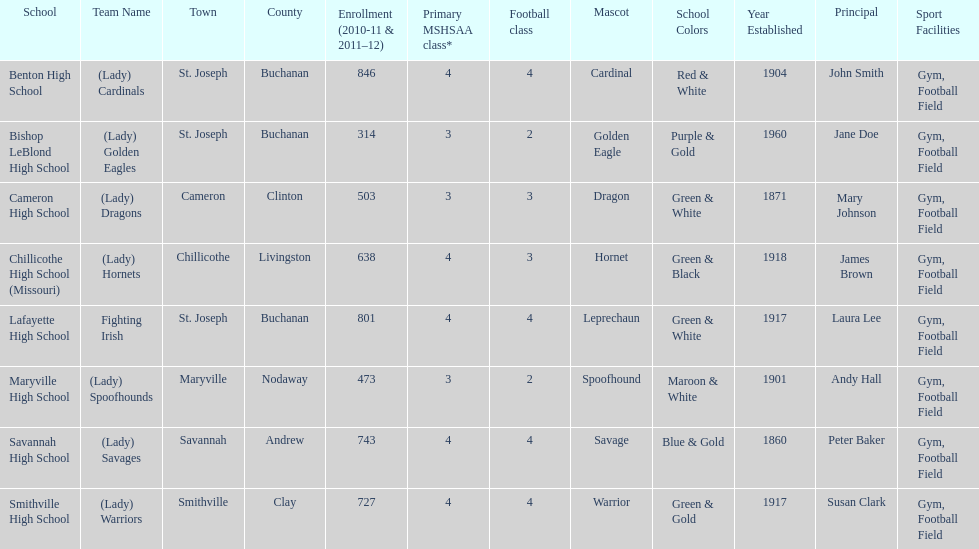Which school has the least amount of student enrollment between 2010-2011 and 2011-2012? Bishop LeBlond High School. 